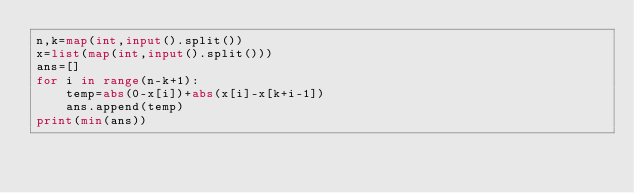<code> <loc_0><loc_0><loc_500><loc_500><_Python_>n,k=map(int,input().split())
x=list(map(int,input().split()))
ans=[]
for i in range(n-k+1):
    temp=abs(0-x[i])+abs(x[i]-x[k+i-1])
    ans.append(temp)
print(min(ans))
</code> 